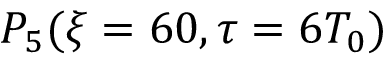<formula> <loc_0><loc_0><loc_500><loc_500>P _ { 5 } ( \xi = 6 0 , \tau = 6 T _ { 0 } )</formula> 